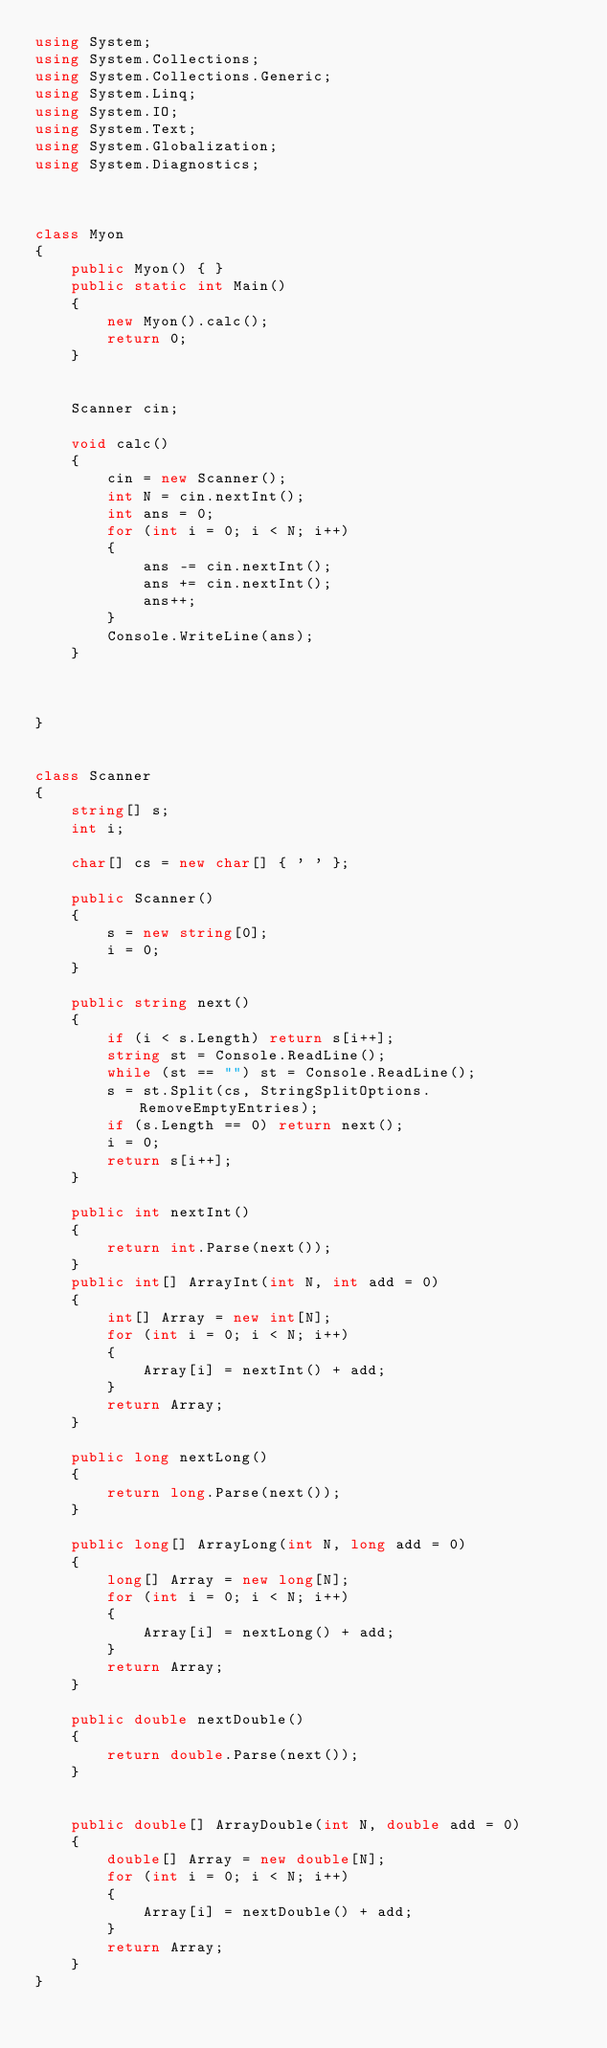<code> <loc_0><loc_0><loc_500><loc_500><_C#_>using System;
using System.Collections;
using System.Collections.Generic;
using System.Linq;
using System.IO;
using System.Text;
using System.Globalization;
using System.Diagnostics;



class Myon
{
    public Myon() { }
    public static int Main()
    {
        new Myon().calc();
        return 0;
    }
    

    Scanner cin;

    void calc()
    {
        cin = new Scanner();
        int N = cin.nextInt();
        int ans = 0;
        for (int i = 0; i < N; i++)
        {
            ans -= cin.nextInt();
            ans += cin.nextInt();
            ans++;
        }
        Console.WriteLine(ans);
    }
    


}


class Scanner
{
    string[] s;
    int i;

    char[] cs = new char[] { ' ' };

    public Scanner()
    {
        s = new string[0];
        i = 0;
    }

    public string next()
    {
        if (i < s.Length) return s[i++];
        string st = Console.ReadLine();
        while (st == "") st = Console.ReadLine();
        s = st.Split(cs, StringSplitOptions.RemoveEmptyEntries);
        if (s.Length == 0) return next();
        i = 0;
        return s[i++];
    }

    public int nextInt()
    {
        return int.Parse(next());
    }
    public int[] ArrayInt(int N, int add = 0)
    {
        int[] Array = new int[N];
        for (int i = 0; i < N; i++)
        {
            Array[i] = nextInt() + add;
        }
        return Array;
    }

    public long nextLong()
    {
        return long.Parse(next());
    }

    public long[] ArrayLong(int N, long add = 0)
    {
        long[] Array = new long[N];
        for (int i = 0; i < N; i++)
        {
            Array[i] = nextLong() + add;
        }
        return Array;
    }

    public double nextDouble()
    {
        return double.Parse(next());
    }


    public double[] ArrayDouble(int N, double add = 0)
    {
        double[] Array = new double[N];
        for (int i = 0; i < N; i++)
        {
            Array[i] = nextDouble() + add;
        }
        return Array;
    }
}
</code> 